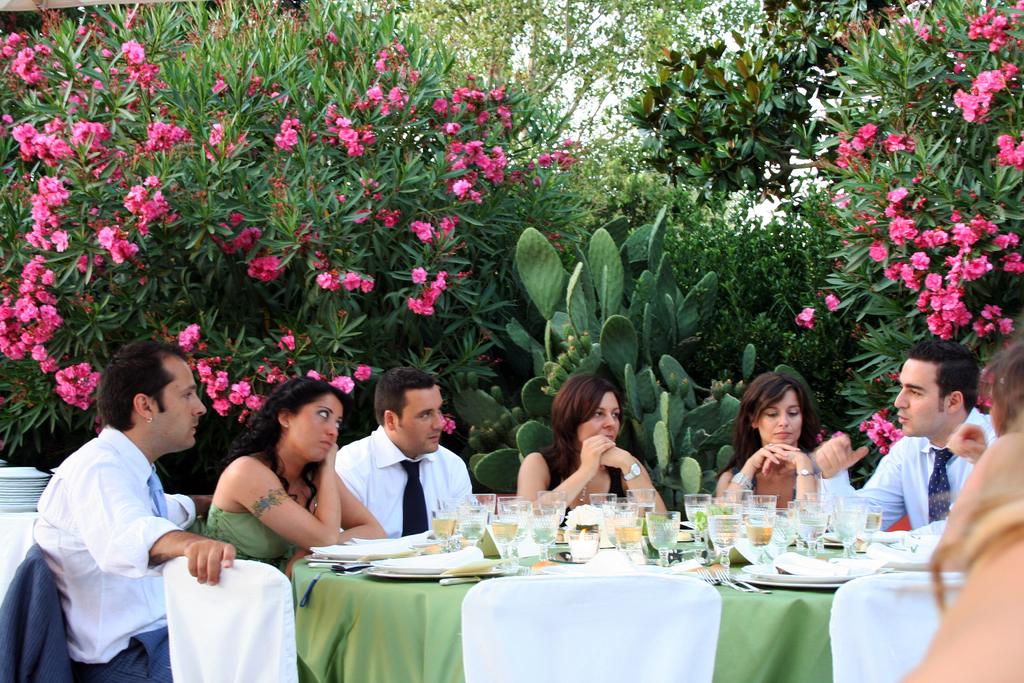What type of vegetation can be seen in the image? There are trees and flowers in the image. What are the people in the image doing? The people are sitting on chairs in the image. What is on the table in the image? There is a table in the image, and it is covered with a green cloth. Additionally, there are plates and glasses on the table. Can you tell me how many horns are visible in the image? There are no horns present in the image. Where is the faucet located in the image? There is no faucet present in the image. 